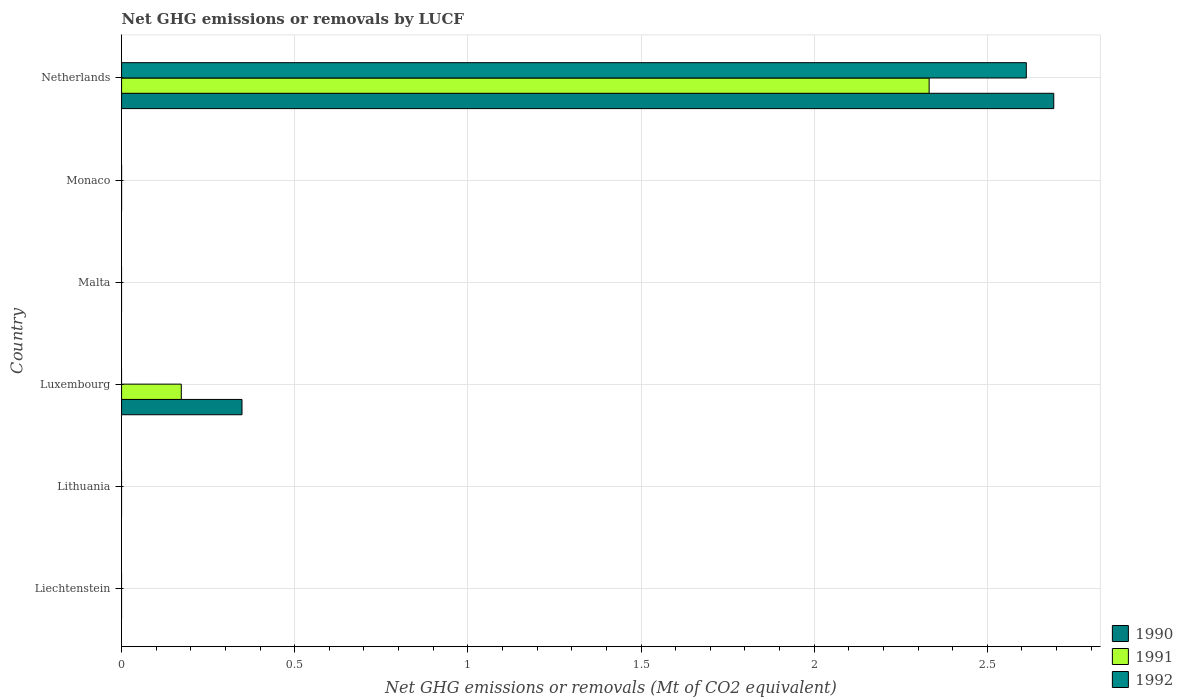Are the number of bars per tick equal to the number of legend labels?
Your answer should be compact. No. How many bars are there on the 2nd tick from the top?
Your answer should be compact. 0. How many bars are there on the 4th tick from the bottom?
Make the answer very short. 0. What is the label of the 4th group of bars from the top?
Provide a succinct answer. Luxembourg. Across all countries, what is the maximum net GHG emissions or removals by LUCF in 1991?
Provide a short and direct response. 2.33. What is the total net GHG emissions or removals by LUCF in 1990 in the graph?
Make the answer very short. 3.04. What is the difference between the net GHG emissions or removals by LUCF in 1990 in Netherlands and the net GHG emissions or removals by LUCF in 1992 in Luxembourg?
Provide a succinct answer. 2.69. What is the average net GHG emissions or removals by LUCF in 1991 per country?
Your response must be concise. 0.42. What is the difference between the net GHG emissions or removals by LUCF in 1990 and net GHG emissions or removals by LUCF in 1992 in Netherlands?
Your answer should be very brief. 0.08. In how many countries, is the net GHG emissions or removals by LUCF in 1991 greater than 2.4 Mt?
Keep it short and to the point. 0. What is the difference between the highest and the lowest net GHG emissions or removals by LUCF in 1992?
Give a very brief answer. 2.61. In how many countries, is the net GHG emissions or removals by LUCF in 1991 greater than the average net GHG emissions or removals by LUCF in 1991 taken over all countries?
Your response must be concise. 1. Is it the case that in every country, the sum of the net GHG emissions or removals by LUCF in 1990 and net GHG emissions or removals by LUCF in 1991 is greater than the net GHG emissions or removals by LUCF in 1992?
Make the answer very short. No. How many bars are there?
Your answer should be very brief. 5. Are all the bars in the graph horizontal?
Keep it short and to the point. Yes. What is the difference between two consecutive major ticks on the X-axis?
Provide a short and direct response. 0.5. Are the values on the major ticks of X-axis written in scientific E-notation?
Provide a succinct answer. No. Does the graph contain grids?
Offer a terse response. Yes. How are the legend labels stacked?
Keep it short and to the point. Vertical. What is the title of the graph?
Make the answer very short. Net GHG emissions or removals by LUCF. What is the label or title of the X-axis?
Your answer should be compact. Net GHG emissions or removals (Mt of CO2 equivalent). What is the Net GHG emissions or removals (Mt of CO2 equivalent) of 1992 in Liechtenstein?
Make the answer very short. 0. What is the Net GHG emissions or removals (Mt of CO2 equivalent) of 1990 in Lithuania?
Give a very brief answer. 0. What is the Net GHG emissions or removals (Mt of CO2 equivalent) in 1991 in Lithuania?
Your response must be concise. 0. What is the Net GHG emissions or removals (Mt of CO2 equivalent) of 1990 in Luxembourg?
Your answer should be very brief. 0.35. What is the Net GHG emissions or removals (Mt of CO2 equivalent) in 1991 in Luxembourg?
Keep it short and to the point. 0.17. What is the Net GHG emissions or removals (Mt of CO2 equivalent) in 1990 in Malta?
Keep it short and to the point. 0. What is the Net GHG emissions or removals (Mt of CO2 equivalent) of 1991 in Monaco?
Your answer should be compact. 0. What is the Net GHG emissions or removals (Mt of CO2 equivalent) in 1990 in Netherlands?
Provide a succinct answer. 2.69. What is the Net GHG emissions or removals (Mt of CO2 equivalent) in 1991 in Netherlands?
Make the answer very short. 2.33. What is the Net GHG emissions or removals (Mt of CO2 equivalent) of 1992 in Netherlands?
Provide a short and direct response. 2.61. Across all countries, what is the maximum Net GHG emissions or removals (Mt of CO2 equivalent) in 1990?
Offer a very short reply. 2.69. Across all countries, what is the maximum Net GHG emissions or removals (Mt of CO2 equivalent) of 1991?
Ensure brevity in your answer.  2.33. Across all countries, what is the maximum Net GHG emissions or removals (Mt of CO2 equivalent) of 1992?
Provide a short and direct response. 2.61. Across all countries, what is the minimum Net GHG emissions or removals (Mt of CO2 equivalent) of 1992?
Provide a succinct answer. 0. What is the total Net GHG emissions or removals (Mt of CO2 equivalent) of 1990 in the graph?
Keep it short and to the point. 3.04. What is the total Net GHG emissions or removals (Mt of CO2 equivalent) of 1991 in the graph?
Provide a succinct answer. 2.5. What is the total Net GHG emissions or removals (Mt of CO2 equivalent) of 1992 in the graph?
Your answer should be very brief. 2.61. What is the difference between the Net GHG emissions or removals (Mt of CO2 equivalent) in 1990 in Luxembourg and that in Netherlands?
Provide a short and direct response. -2.34. What is the difference between the Net GHG emissions or removals (Mt of CO2 equivalent) of 1991 in Luxembourg and that in Netherlands?
Offer a terse response. -2.16. What is the difference between the Net GHG emissions or removals (Mt of CO2 equivalent) in 1990 in Luxembourg and the Net GHG emissions or removals (Mt of CO2 equivalent) in 1991 in Netherlands?
Your answer should be compact. -1.98. What is the difference between the Net GHG emissions or removals (Mt of CO2 equivalent) of 1990 in Luxembourg and the Net GHG emissions or removals (Mt of CO2 equivalent) of 1992 in Netherlands?
Your response must be concise. -2.26. What is the difference between the Net GHG emissions or removals (Mt of CO2 equivalent) in 1991 in Luxembourg and the Net GHG emissions or removals (Mt of CO2 equivalent) in 1992 in Netherlands?
Keep it short and to the point. -2.44. What is the average Net GHG emissions or removals (Mt of CO2 equivalent) of 1990 per country?
Make the answer very short. 0.51. What is the average Net GHG emissions or removals (Mt of CO2 equivalent) of 1991 per country?
Make the answer very short. 0.42. What is the average Net GHG emissions or removals (Mt of CO2 equivalent) of 1992 per country?
Your answer should be very brief. 0.44. What is the difference between the Net GHG emissions or removals (Mt of CO2 equivalent) in 1990 and Net GHG emissions or removals (Mt of CO2 equivalent) in 1991 in Luxembourg?
Offer a very short reply. 0.18. What is the difference between the Net GHG emissions or removals (Mt of CO2 equivalent) of 1990 and Net GHG emissions or removals (Mt of CO2 equivalent) of 1991 in Netherlands?
Offer a terse response. 0.36. What is the difference between the Net GHG emissions or removals (Mt of CO2 equivalent) in 1990 and Net GHG emissions or removals (Mt of CO2 equivalent) in 1992 in Netherlands?
Offer a very short reply. 0.08. What is the difference between the Net GHG emissions or removals (Mt of CO2 equivalent) of 1991 and Net GHG emissions or removals (Mt of CO2 equivalent) of 1992 in Netherlands?
Provide a succinct answer. -0.28. What is the ratio of the Net GHG emissions or removals (Mt of CO2 equivalent) of 1990 in Luxembourg to that in Netherlands?
Keep it short and to the point. 0.13. What is the ratio of the Net GHG emissions or removals (Mt of CO2 equivalent) in 1991 in Luxembourg to that in Netherlands?
Provide a short and direct response. 0.07. What is the difference between the highest and the lowest Net GHG emissions or removals (Mt of CO2 equivalent) of 1990?
Your answer should be very brief. 2.69. What is the difference between the highest and the lowest Net GHG emissions or removals (Mt of CO2 equivalent) in 1991?
Offer a terse response. 2.33. What is the difference between the highest and the lowest Net GHG emissions or removals (Mt of CO2 equivalent) in 1992?
Offer a very short reply. 2.61. 